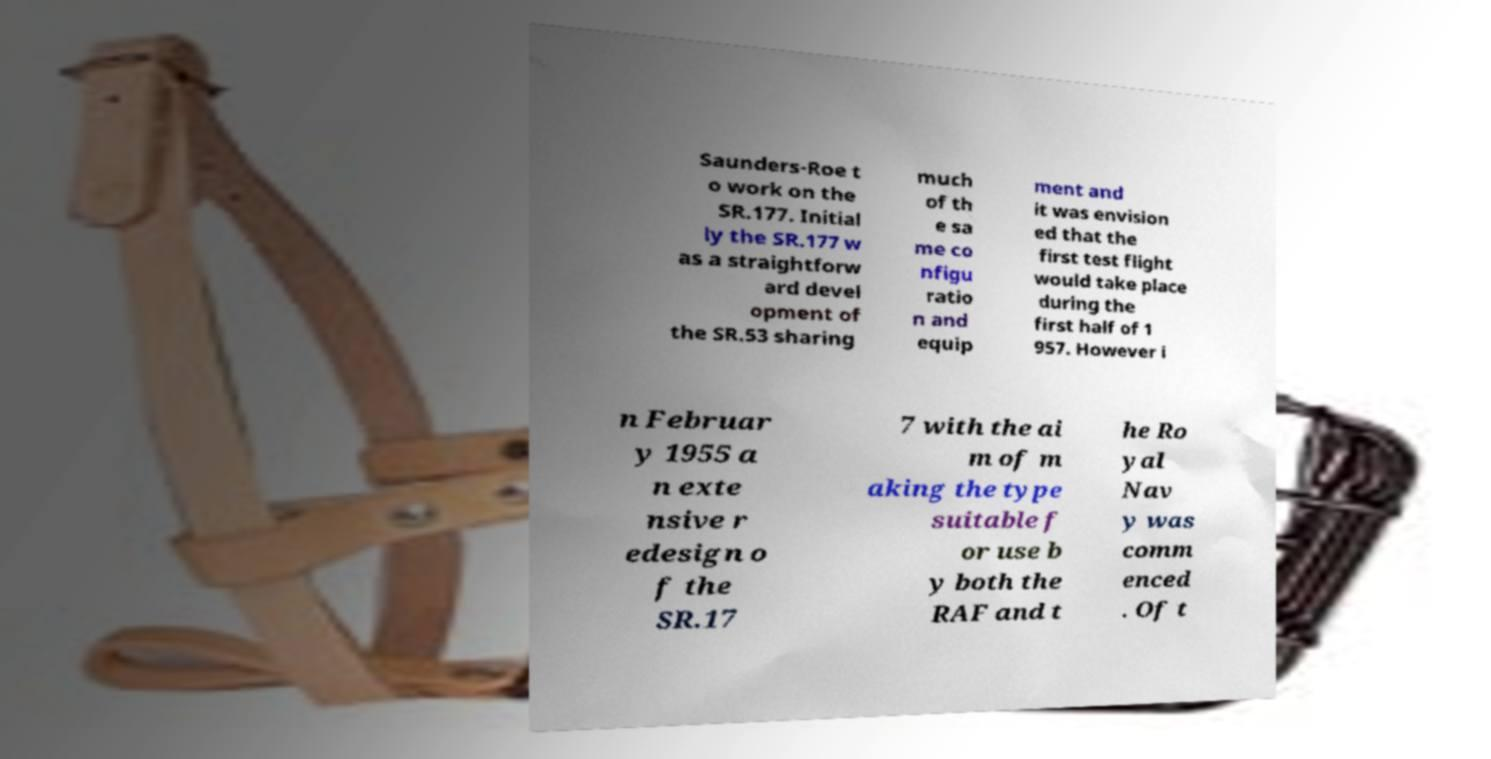Please identify and transcribe the text found in this image. Saunders-Roe t o work on the SR.177. Initial ly the SR.177 w as a straightforw ard devel opment of the SR.53 sharing much of th e sa me co nfigu ratio n and equip ment and it was envision ed that the first test flight would take place during the first half of 1 957. However i n Februar y 1955 a n exte nsive r edesign o f the SR.17 7 with the ai m of m aking the type suitable f or use b y both the RAF and t he Ro yal Nav y was comm enced . Of t 